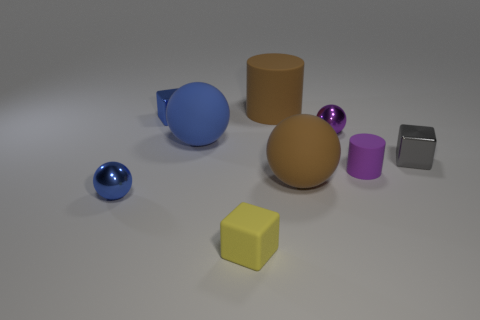Add 1 cyan shiny spheres. How many objects exist? 10 Subtract all cubes. How many objects are left? 6 Add 4 big rubber balls. How many big rubber balls are left? 6 Add 9 large gray blocks. How many large gray blocks exist? 9 Subtract 0 red cubes. How many objects are left? 9 Subtract all big brown metallic balls. Subtract all tiny blue blocks. How many objects are left? 8 